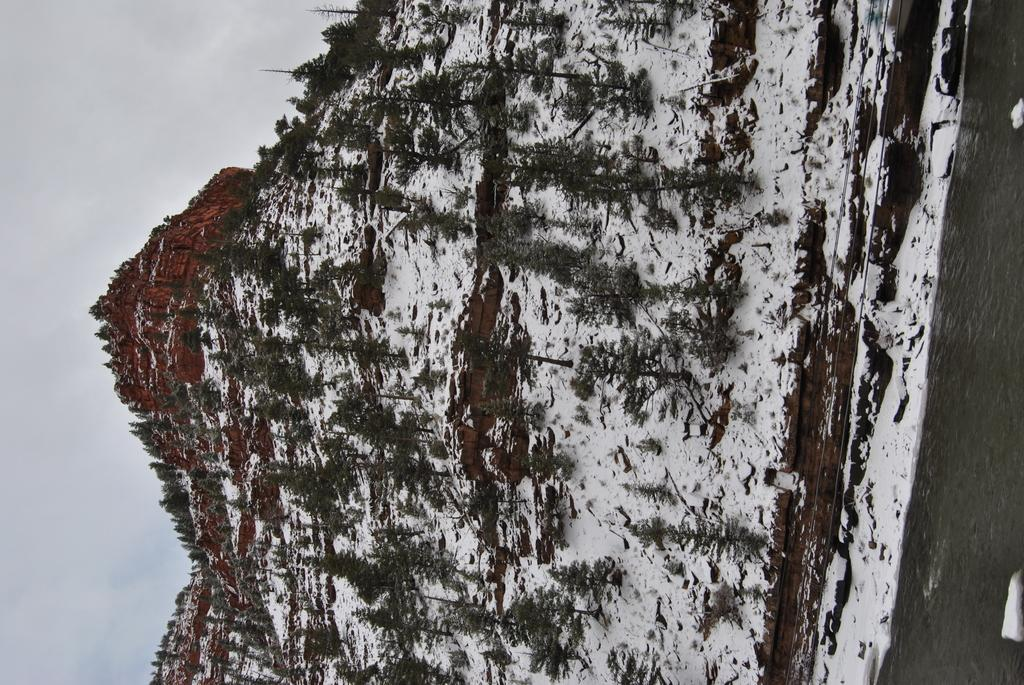What natural elements can be seen in the image? There is water, snow, trees, and a mountain in the image. What is visible in the background of the image? The sky is visible in the background of the image. What type of terrain is depicted in the image? The image features a mountainous landscape with trees and snow. What type of heart design can be seen on the mountain in the image? There is no heart design present on the mountain in the image; it is a natural landscape. 